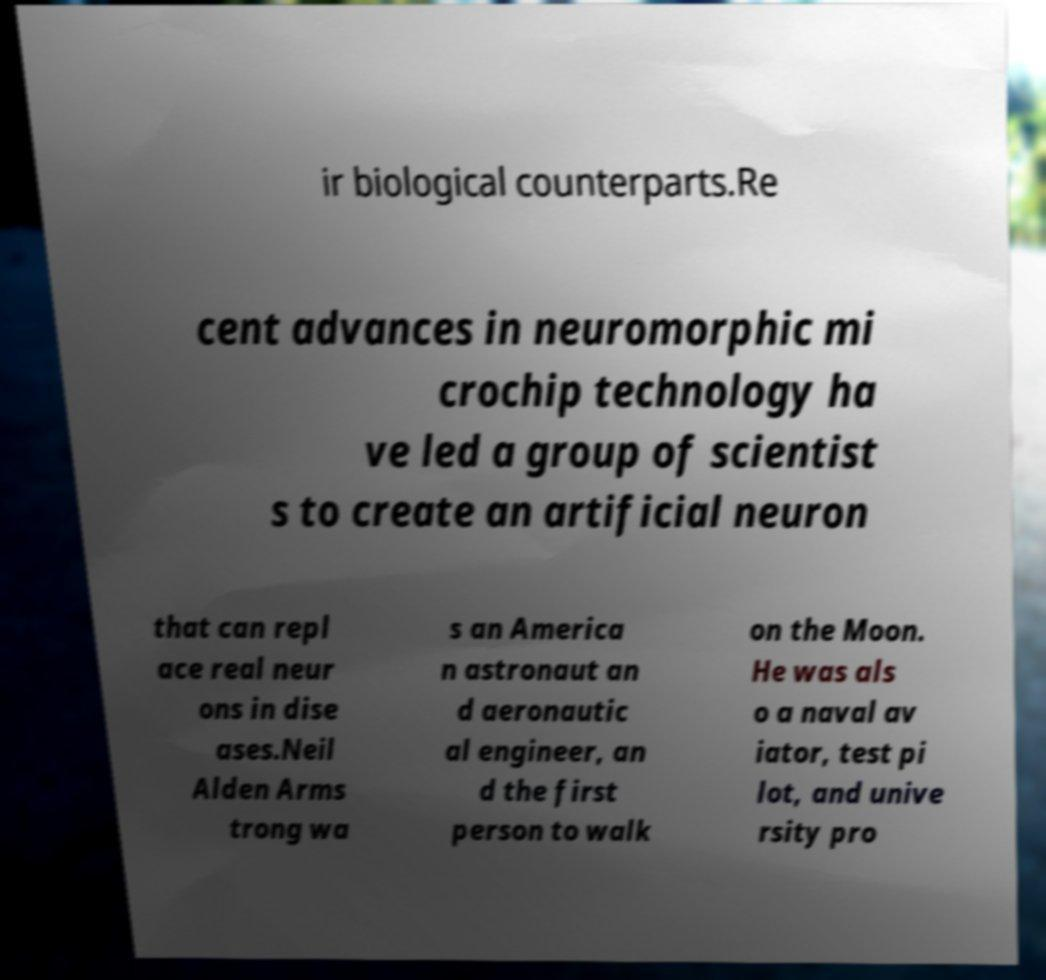Can you accurately transcribe the text from the provided image for me? ir biological counterparts.Re cent advances in neuromorphic mi crochip technology ha ve led a group of scientist s to create an artificial neuron that can repl ace real neur ons in dise ases.Neil Alden Arms trong wa s an America n astronaut an d aeronautic al engineer, an d the first person to walk on the Moon. He was als o a naval av iator, test pi lot, and unive rsity pro 